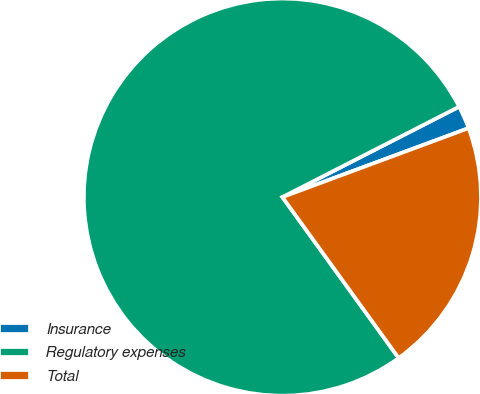Convert chart. <chart><loc_0><loc_0><loc_500><loc_500><pie_chart><fcel>Insurance<fcel>Regulatory expenses<fcel>Total<nl><fcel>1.88%<fcel>77.43%<fcel>20.69%<nl></chart> 